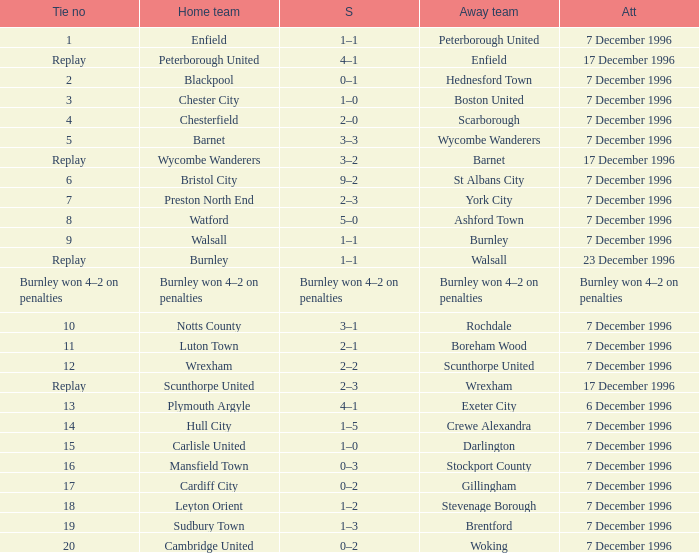What was the score of tie number 15? 1–0. 